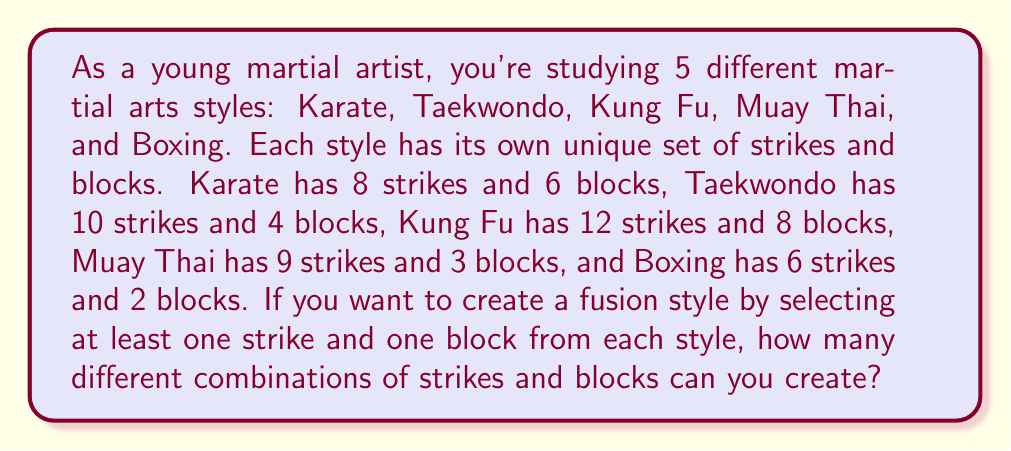What is the answer to this math problem? To solve this problem, we'll use the multiplication principle of counting. We need to:

1. Count the number of ways to choose strikes from each style
2. Count the number of ways to choose blocks from each style
3. Multiply these numbers together

For each style, we have two choices: either select at least one strike/block or don't select any. The number of ways to select at least one item from a set of $n$ items is $2^n - 1$ (all possible combinations minus the empty set).

Let's calculate for each style:

Karate:
- Strikes: $2^8 - 1 = 255$ ways
- Blocks: $2^6 - 1 = 63$ ways

Taekwondo:
- Strikes: $2^{10} - 1 = 1023$ ways
- Blocks: $2^4 - 1 = 15$ ways

Kung Fu:
- Strikes: $2^{12} - 1 = 4095$ ways
- Blocks: $2^8 - 1 = 255$ ways

Muay Thai:
- Strikes: $2^9 - 1 = 511$ ways
- Blocks: $2^3 - 1 = 7$ ways

Boxing:
- Strikes: $2^6 - 1 = 63$ ways
- Blocks: $2^2 - 1 = 3$ ways

Now, we multiply all these numbers together:

$$255 \cdot 63 \cdot 1023 \cdot 15 \cdot 4095 \cdot 255 \cdot 511 \cdot 7 \cdot 63 \cdot 3$$

This gives us the total number of possible combinations.
Answer: The total number of different combinations of strikes and blocks for your fusion style is:

$$255 \cdot 63 \cdot 1023 \cdot 15 \cdot 4095 \cdot 255 \cdot 511 \cdot 7 \cdot 63 \cdot 3 = 1,007,442,171,887,098,875,000$$

or approximately $1.01 \times 10^{21}$ combinations. 